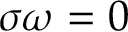Convert formula to latex. <formula><loc_0><loc_0><loc_500><loc_500>\sigma \omega = 0</formula> 